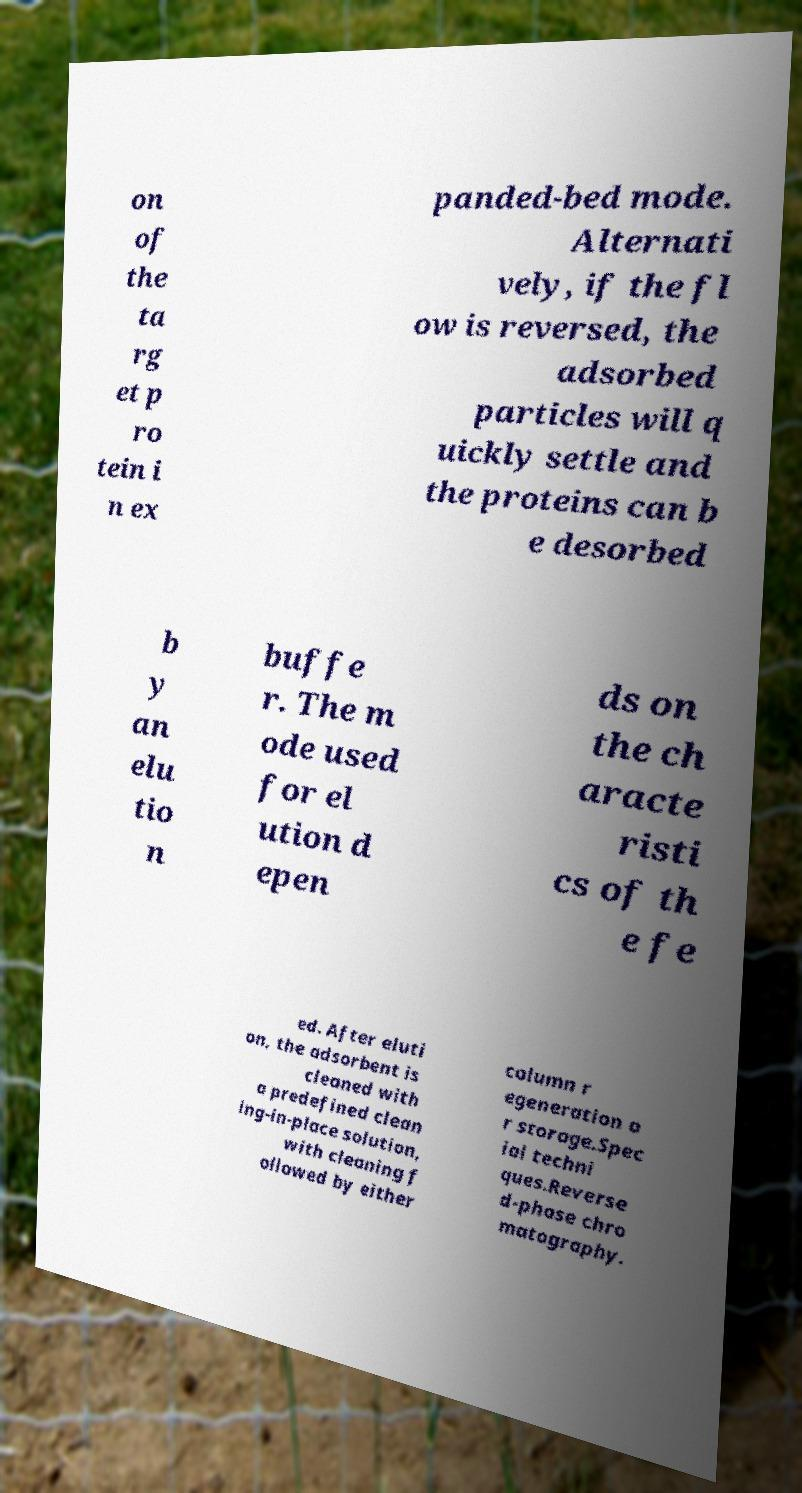Please read and relay the text visible in this image. What does it say? on of the ta rg et p ro tein i n ex panded-bed mode. Alternati vely, if the fl ow is reversed, the adsorbed particles will q uickly settle and the proteins can b e desorbed b y an elu tio n buffe r. The m ode used for el ution d epen ds on the ch aracte risti cs of th e fe ed. After eluti on, the adsorbent is cleaned with a predefined clean ing-in-place solution, with cleaning f ollowed by either column r egeneration o r storage.Spec ial techni ques.Reverse d-phase chro matography. 